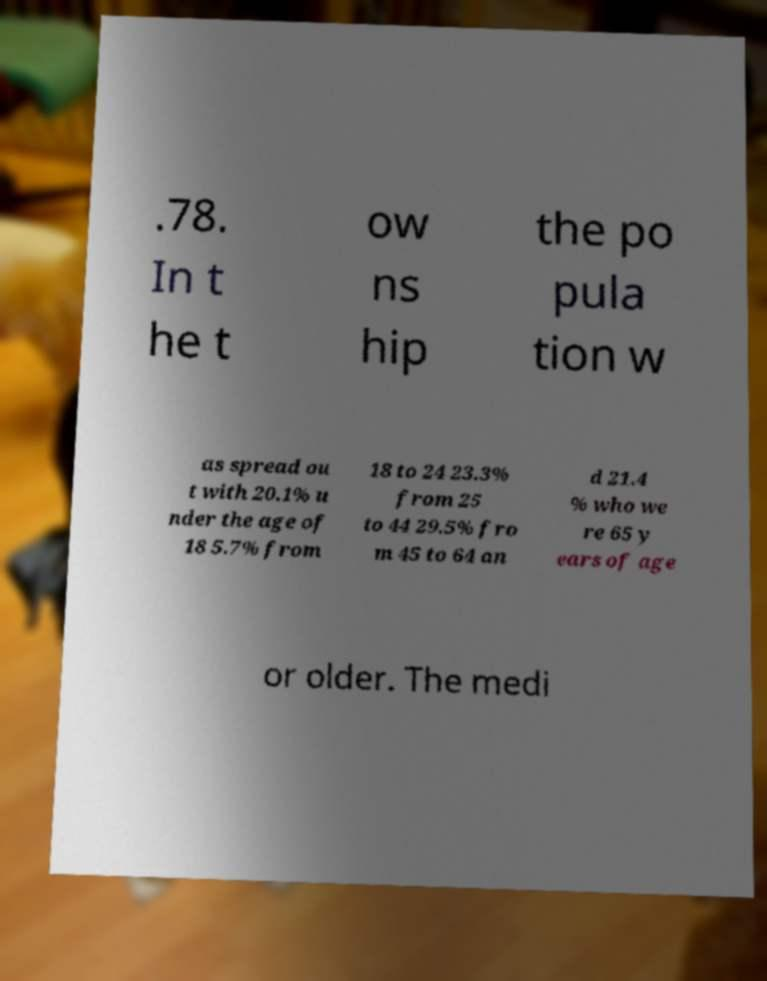There's text embedded in this image that I need extracted. Can you transcribe it verbatim? .78. In t he t ow ns hip the po pula tion w as spread ou t with 20.1% u nder the age of 18 5.7% from 18 to 24 23.3% from 25 to 44 29.5% fro m 45 to 64 an d 21.4 % who we re 65 y ears of age or older. The medi 